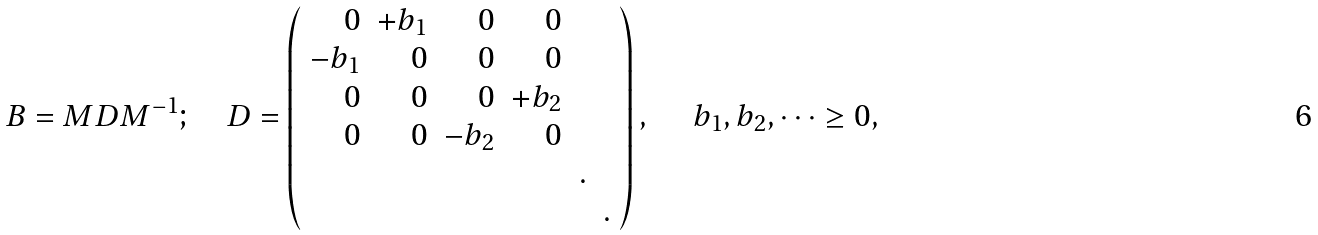<formula> <loc_0><loc_0><loc_500><loc_500>B = M D M ^ { - 1 } ; \quad D = \left ( \begin{array} { r r r r r r } 0 & + b _ { 1 } & 0 & 0 \\ - b _ { 1 } & 0 & 0 & 0 \\ 0 & 0 & 0 & + b _ { 2 } \\ 0 & 0 & - b _ { 2 } & 0 & \\ & & & & . \\ & & & & & . \\ \end{array} \right ) , \quad \ b _ { 1 } , b _ { 2 } , \dots \geq 0 ,</formula> 